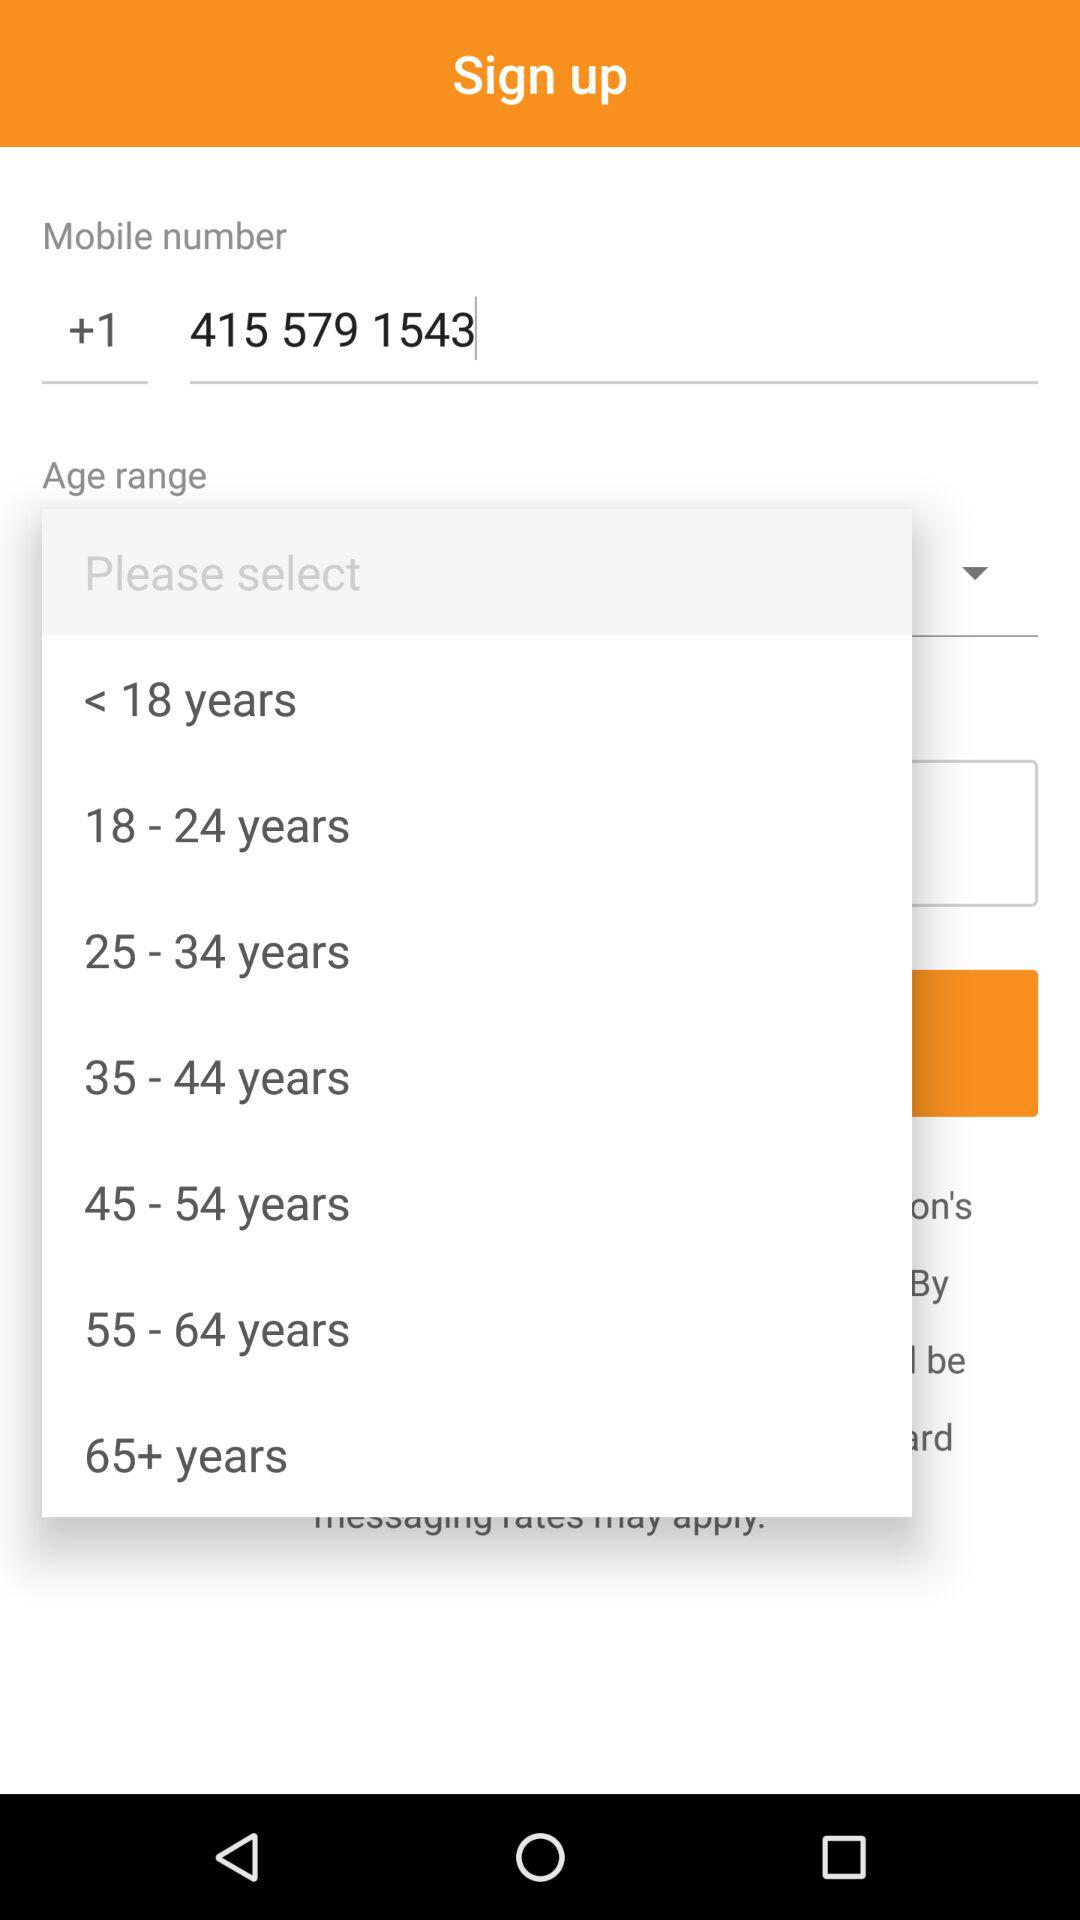How many age ranges are available?
Answer the question using a single word or phrase. 7 